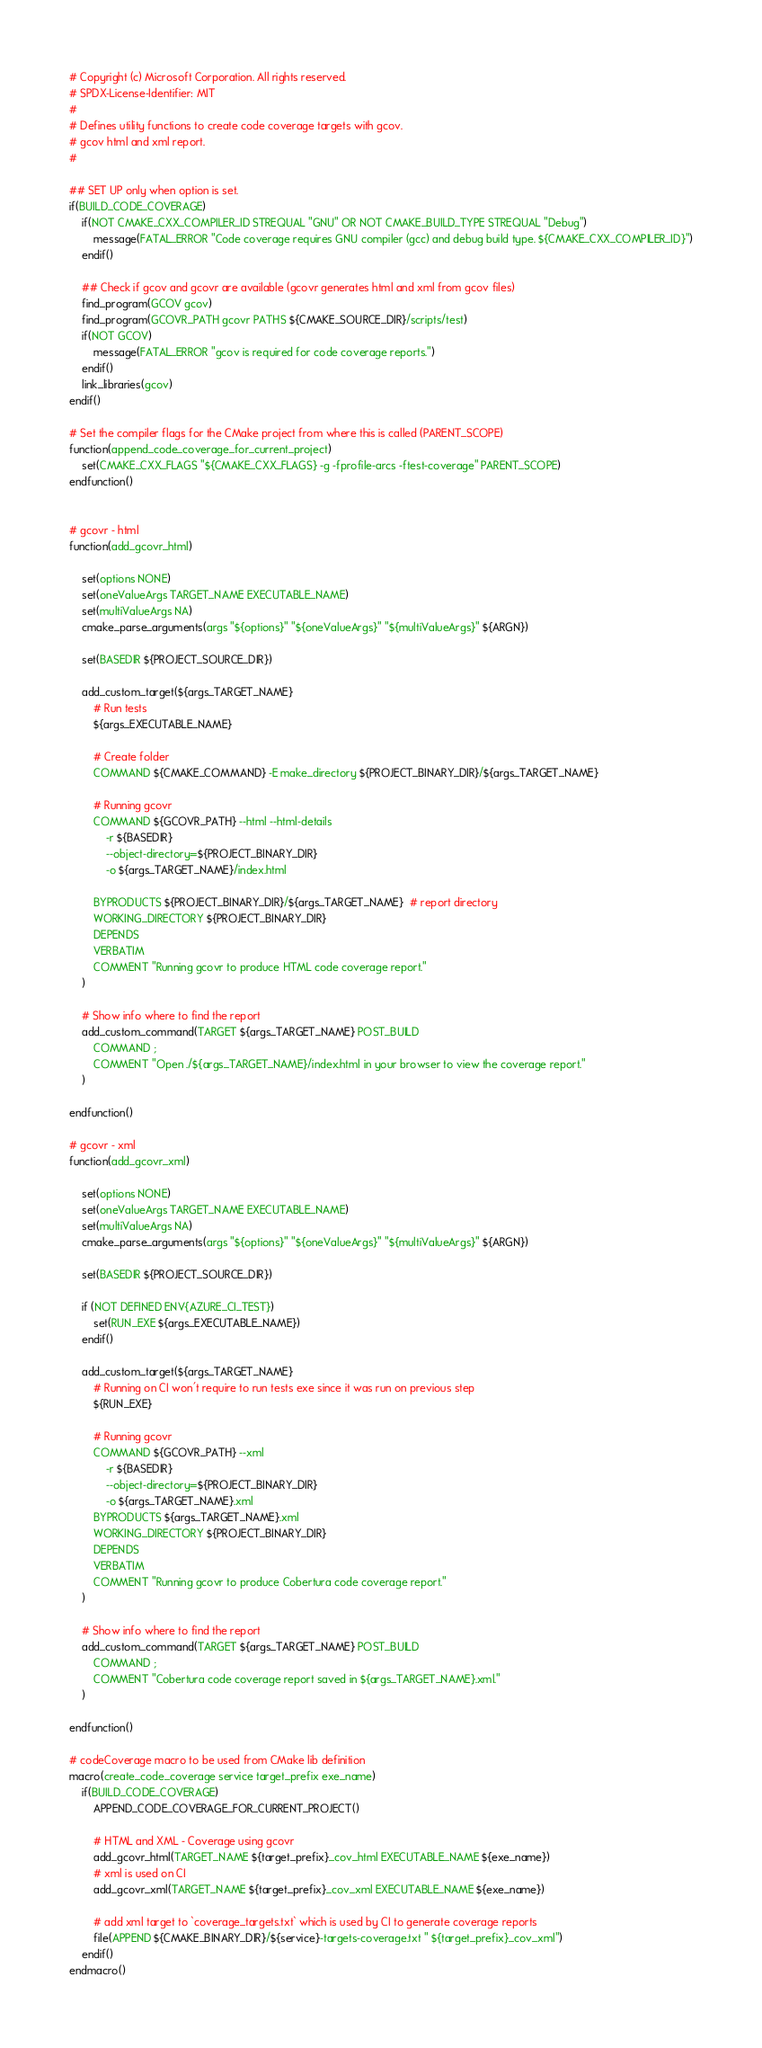Convert code to text. <code><loc_0><loc_0><loc_500><loc_500><_CMake_># Copyright (c) Microsoft Corporation. All rights reserved.
# SPDX-License-Identifier: MIT
#
# Defines utility functions to create code coverage targets with gcov.
# gcov html and xml report.
#

## SET UP only when option is set. 
if(BUILD_CODE_COVERAGE)
    if(NOT CMAKE_CXX_COMPILER_ID STREQUAL "GNU" OR NOT CMAKE_BUILD_TYPE STREQUAL "Debug")
        message(FATAL_ERROR "Code coverage requires GNU compiler (gcc) and debug build type. ${CMAKE_CXX_COMPILER_ID}")
    endif()

    ## Check if gcov and gcovr are available (gcovr generates html and xml from gcov files)
    find_program(GCOV gcov)
    find_program(GCOVR_PATH gcovr PATHS ${CMAKE_SOURCE_DIR}/scripts/test)
    if(NOT GCOV)
        message(FATAL_ERROR "gcov is required for code coverage reports.")
    endif()
    link_libraries(gcov)
endif()

# Set the compiler flags for the CMake project from where this is called (PARENT_SCOPE)
function(append_code_coverage_for_current_project)
    set(CMAKE_CXX_FLAGS "${CMAKE_CXX_FLAGS} -g -fprofile-arcs -ftest-coverage" PARENT_SCOPE)
endfunction()


# gcovr - html
function(add_gcovr_html)

    set(options NONE)
    set(oneValueArgs TARGET_NAME EXECUTABLE_NAME)
    set(multiValueArgs NA)
    cmake_parse_arguments(args "${options}" "${oneValueArgs}" "${multiValueArgs}" ${ARGN})

    set(BASEDIR ${PROJECT_SOURCE_DIR})

    add_custom_target(${args_TARGET_NAME}
        # Run tests
        ${args_EXECUTABLE_NAME}

        # Create folder
        COMMAND ${CMAKE_COMMAND} -E make_directory ${PROJECT_BINARY_DIR}/${args_TARGET_NAME}

        # Running gcovr
        COMMAND ${GCOVR_PATH} --html --html-details
            -r ${BASEDIR}
            --object-directory=${PROJECT_BINARY_DIR}
            -o ${args_TARGET_NAME}/index.html

        BYPRODUCTS ${PROJECT_BINARY_DIR}/${args_TARGET_NAME}  # report directory
        WORKING_DIRECTORY ${PROJECT_BINARY_DIR}
        DEPENDS
        VERBATIM
        COMMENT "Running gcovr to produce HTML code coverage report."
    )

    # Show info where to find the report
    add_custom_command(TARGET ${args_TARGET_NAME} POST_BUILD
        COMMAND ;
        COMMENT "Open ./${args_TARGET_NAME}/index.html in your browser to view the coverage report."
    )

endfunction()

# gcovr - xml
function(add_gcovr_xml)

    set(options NONE)
    set(oneValueArgs TARGET_NAME EXECUTABLE_NAME)
    set(multiValueArgs NA)
    cmake_parse_arguments(args "${options}" "${oneValueArgs}" "${multiValueArgs}" ${ARGN})

    set(BASEDIR ${PROJECT_SOURCE_DIR})

    if (NOT DEFINED ENV{AZURE_CI_TEST})
        set(RUN_EXE ${args_EXECUTABLE_NAME})
    endif()
    
    add_custom_target(${args_TARGET_NAME}
        # Running on CI won't require to run tests exe since it was run on previous step
        ${RUN_EXE}

        # Running gcovr
        COMMAND ${GCOVR_PATH} --xml
            -r ${BASEDIR}
            --object-directory=${PROJECT_BINARY_DIR}
            -o ${args_TARGET_NAME}.xml
        BYPRODUCTS ${args_TARGET_NAME}.xml
        WORKING_DIRECTORY ${PROJECT_BINARY_DIR}
        DEPENDS
        VERBATIM
        COMMENT "Running gcovr to produce Cobertura code coverage report."
    )

    # Show info where to find the report
    add_custom_command(TARGET ${args_TARGET_NAME} POST_BUILD
        COMMAND ;
        COMMENT "Cobertura code coverage report saved in ${args_TARGET_NAME}.xml."
    )

endfunction()

# codeCoverage macro to be used from CMake lib definition
macro(create_code_coverage service target_prefix exe_name)
    if(BUILD_CODE_COVERAGE)
        APPEND_CODE_COVERAGE_FOR_CURRENT_PROJECT()

        # HTML and XML - Coverage using gcovr
        add_gcovr_html(TARGET_NAME ${target_prefix}_cov_html EXECUTABLE_NAME ${exe_name})
        # xml is used on CI
        add_gcovr_xml(TARGET_NAME ${target_prefix}_cov_xml EXECUTABLE_NAME ${exe_name})

        # add xml target to `coverage_targets.txt` which is used by CI to generate coverage reports
        file(APPEND ${CMAKE_BINARY_DIR}/${service}-targets-coverage.txt " ${target_prefix}_cov_xml")
    endif()
endmacro()
</code> 